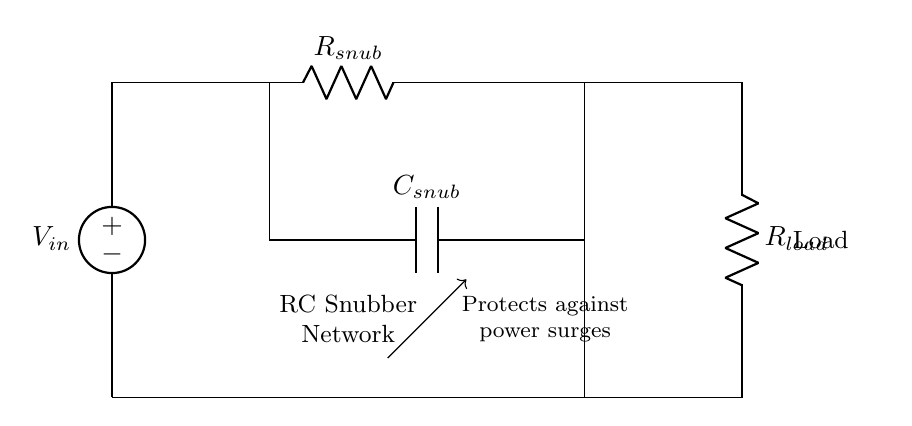What is the purpose of the RC snubber circuit? The purpose of the RC snubber circuit is to protect connected devices from power surges by dissipating excess energy. This is achieved through the resistor-capacitor configuration, which absorbs and smooths out voltage spikes.
Answer: Protects against power surges What is the value of the resistor labeled R snub? R snub is indicated as R snub in the circuit, which implies that its specific value is determined by the design requirements and is not provided in the diagram itself. The value would typically depend on the application and desired surge protection level.
Answer: R snub What type of components are used in this circuit? The circuit employs a resistor and a capacitor, which are passive components commonly used in electronics for filtering and voltage control applications, specifically for snubbing in this case.
Answer: Resistor and capacitor How does the capacitor's role in the snubber circuit affect voltage spikes? The capacitor in the snubber circuit absorbs and stores energy from the voltage spike, preventing it from reaching sensitive electronic components. This helps to limit the rate of rise of voltage, thus protecting the load.
Answer: Absorbs energy from voltage spikes What would happen if the RC snubber circuit was not used? Without the RC snubber circuit, voltage spikes could directly reach the load, potentially damaging sensitive electronics due to their high amplitude and rate of change. This can lead to failure or degradation of the devices.
Answer: Electronics may be damaged What is the effect of increasing the capacitance value in the RC snubber? Increasing the capacitance would allow the circuit to absorb more energy from voltage spikes, potentially improving surge protection. However, it may also affect the circuit's response time and create longer settling times for the voltage level.
Answer: Improved surge protection 